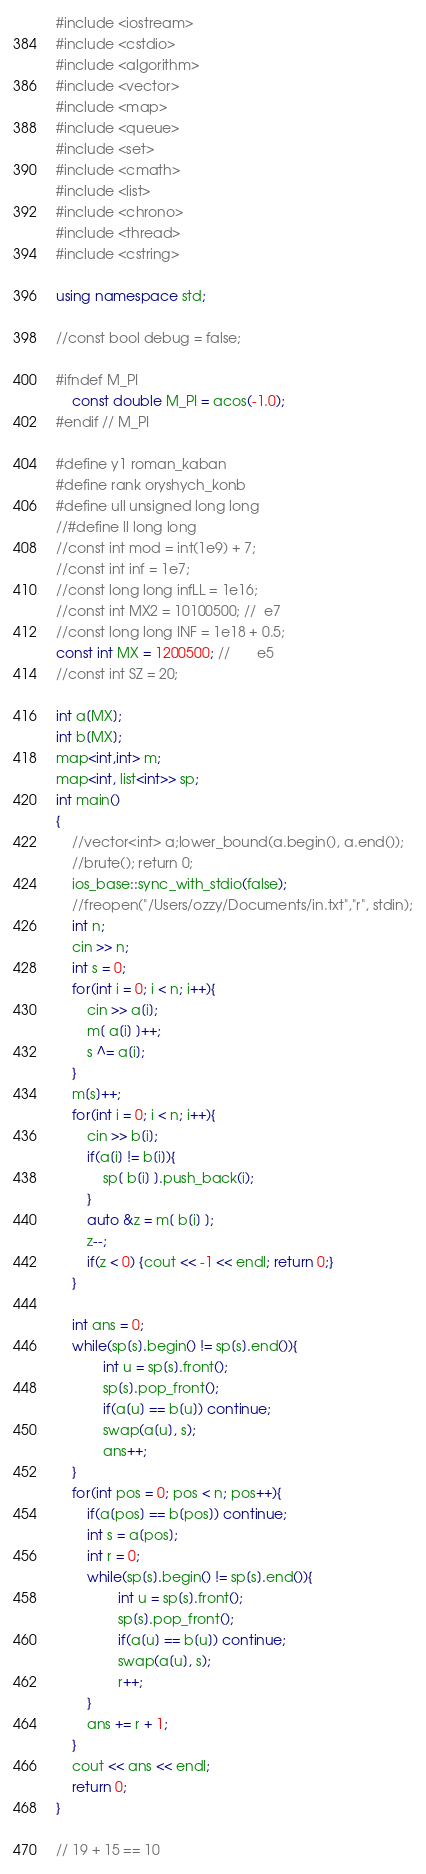<code> <loc_0><loc_0><loc_500><loc_500><_C++_>#include <iostream>
#include <cstdio>
#include <algorithm>
#include <vector>
#include <map>
#include <queue>
#include <set>
#include <cmath>
#include <list>
#include <chrono>
#include <thread>
#include <cstring>

using namespace std;

//const bool debug = false;

#ifndef M_PI
    const double M_PI = acos(-1.0);
#endif // M_PI

#define y1 roman_kaban
#define rank oryshych_konb
#define ull unsigned long long
//#define ll long long
//const int mod = int(1e9) + 7;
//const int inf = 1e7;
//const long long infLL = 1e16;
//const int MX2 = 10100500; //  e7
//const long long INF = 1e18 + 0.5;
const int MX = 1200500; //       e5
//const int SZ = 20;

int a[MX];
int b[MX];
map<int,int> m;
map<int, list<int>> sp;
int main()
{
    //vector<int> a;lower_bound(a.begin(), a.end());
    //brute(); return 0;
    ios_base::sync_with_stdio(false);
    //freopen("/Users/ozzy/Documents/in.txt","r", stdin);
    int n;
    cin >> n;
    int s = 0;
    for(int i = 0; i < n; i++){
        cin >> a[i];
        m[ a[i] ]++;
        s ^= a[i];
    }
    m[s]++;
    for(int i = 0; i < n; i++){
        cin >> b[i];
        if(a[i] != b[i]){
            sp[ b[i] ].push_back(i);
        }
        auto &z = m[ b[i] ];
        z--;
        if(z < 0) {cout << -1 << endl; return 0;}
    }

    int ans = 0;
    while(sp[s].begin() != sp[s].end()){
            int u = sp[s].front();
            sp[s].pop_front();
            if(a[u] == b[u]) continue;
            swap(a[u], s);
            ans++;
    }
    for(int pos = 0; pos < n; pos++){
        if(a[pos] == b[pos]) continue;
        int s = a[pos];
        int r = 0;
        while(sp[s].begin() != sp[s].end()){
                int u = sp[s].front();
                sp[s].pop_front();
                if(a[u] == b[u]) continue;
                swap(a[u], s);
                r++;
        }
        ans += r + 1;
    }
    cout << ans << endl;
    return 0;
}

// 19 + 15 == 10
</code> 